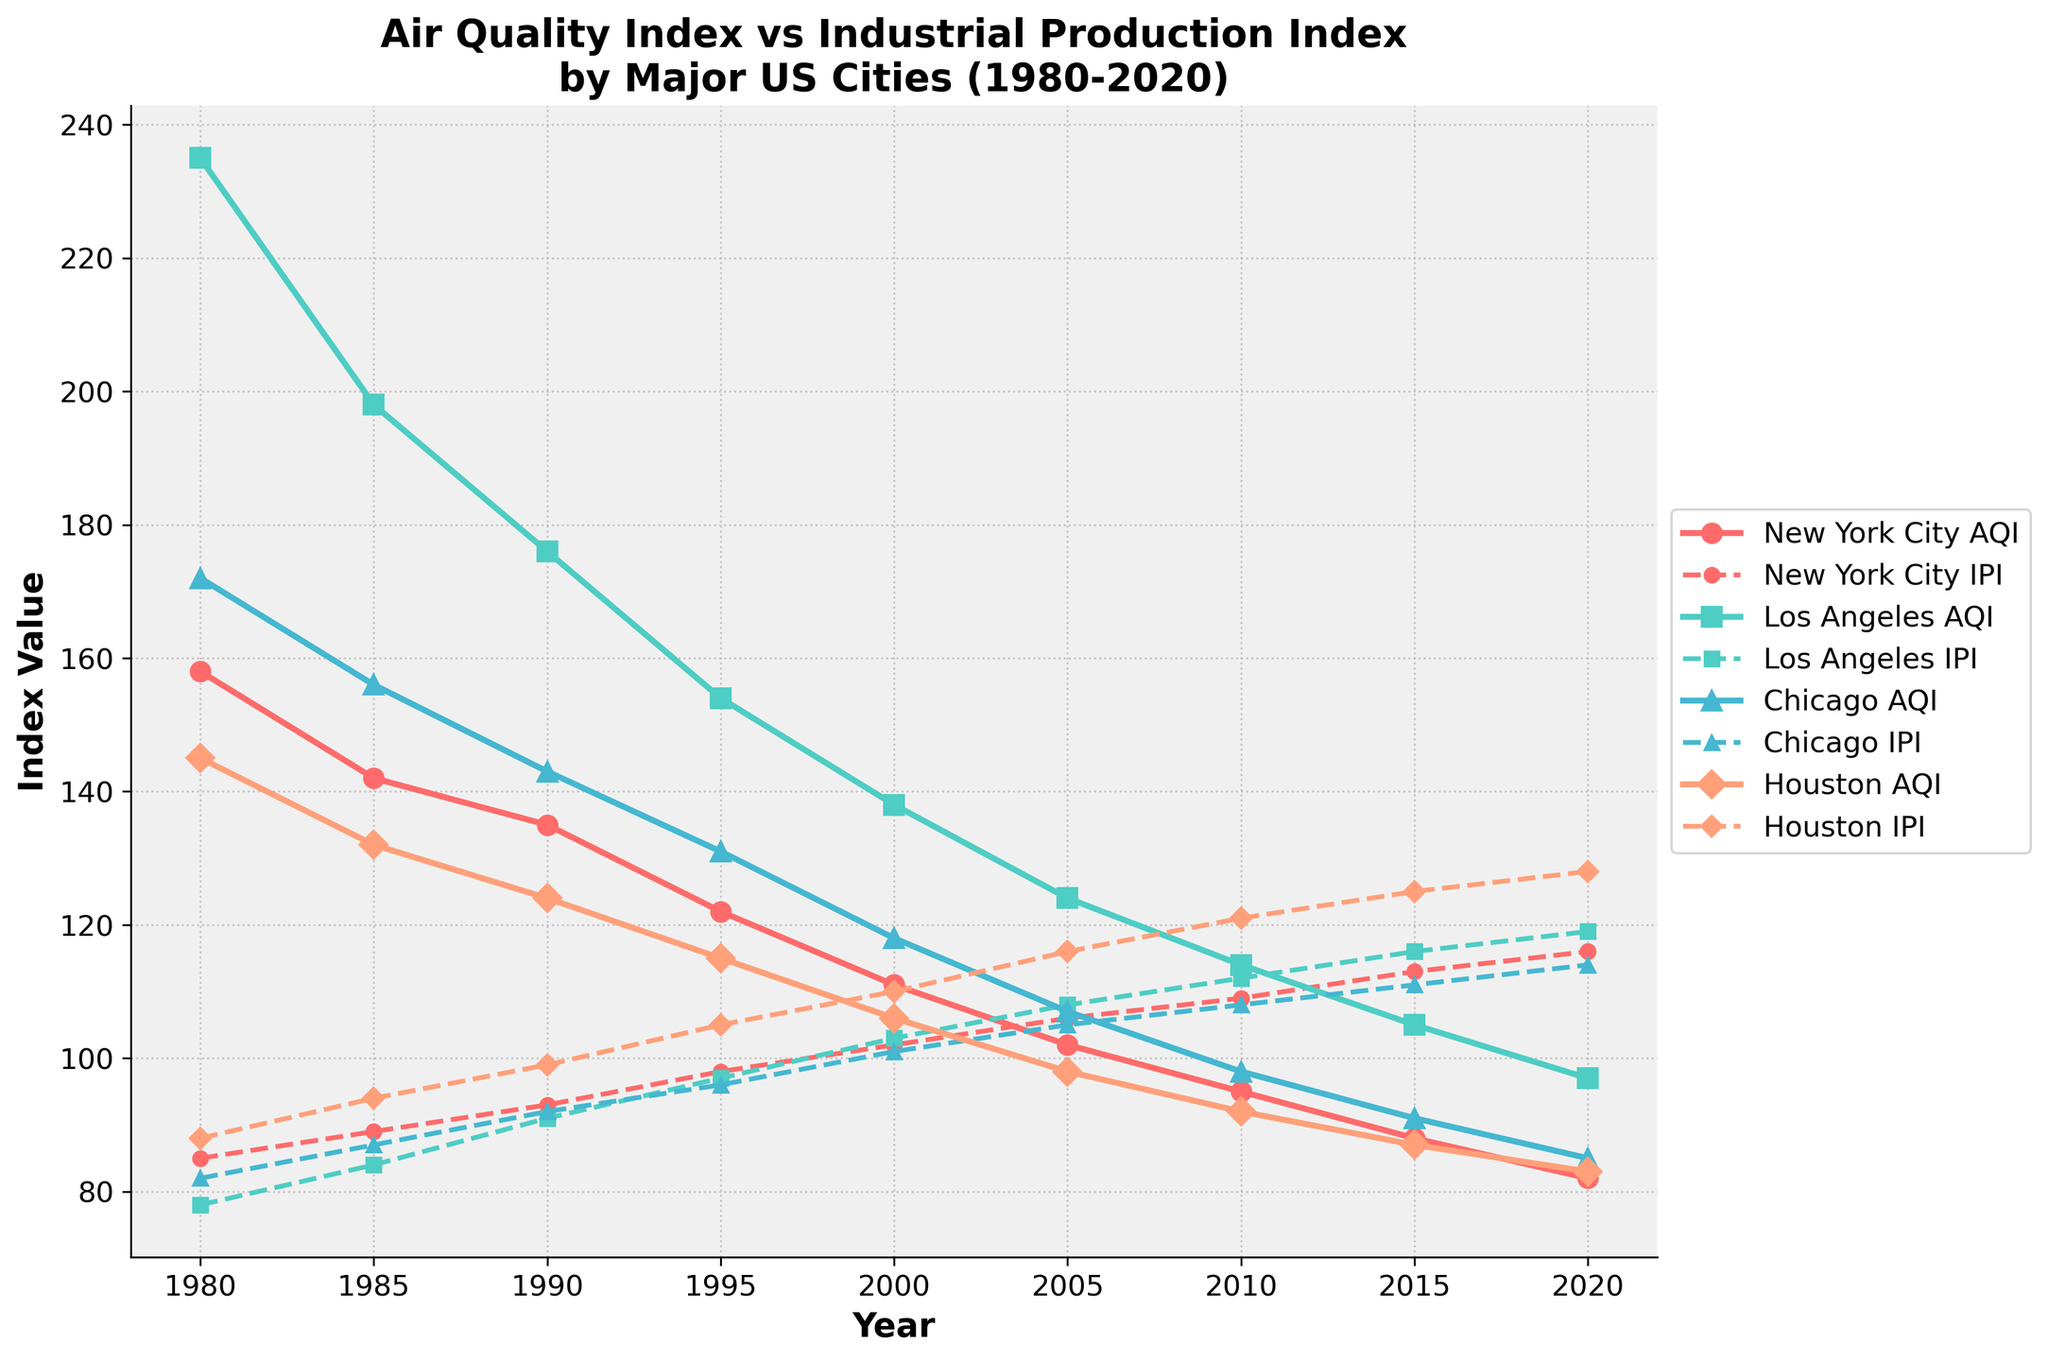What's the general trend of the New York City AQI from 1980 to 2020? The New York City AQI shows a consistent decline over the years, starting at 158 in 1980 and decreasing to 82 in 2020. This indicates an improvement in air quality over this period.
Answer: Decline Are the trends of the AQI and Industrial Production Index for Houston aligned? Observing the figure, Houston's AQI shows a downward trend, starting at 145 in 1980 and reducing to 83 in 2020. In contrast, the Industrial Production Index shows an upward trend, starting at 88 in 1980 and increasing to 128 in 2020.
Answer: No Which city had the highest AQI in the year 1985? By examining the data points for the year 1985 on the figure, Los Angeles had the highest AQI at 198, compared to New York City (142), Chicago (156), and Houston (132).
Answer: Los Angeles Between New York City and Chicago, which city shows a greater overall improvement in AQI from 1980 to 2020? For New York City, the AQI improved from 158 to 82, a reduction of 76 points. For Chicago, the AQI improved from 172 to 85, a reduction of 87 points. Therefore, Chicago shows a greater improvement.
Answer: Chicago What was the AQI difference between Los Angeles and Houston in 2020? In 2020, the AQI for Los Angeles was 97 and for Houston, it was 83. The difference between them is 97 - 83 = 14.
Answer: 14 How does Los Angeles’ trend of AQI compare to its Industrial Production Index over the years? Los Angeles’ AQI shows a downward trend from 235 in 1980 to 97 in 2020. Conversely, its Industrial Production Index shows an upward trend from 78 in 1980 to 119 in 2020. The trends are inversely related.
Answer: Inversely related What is the average AQI of Chicago for the years 1980 and 2020? The AQI for Chicago in 1980 was 172 and in 2020 it was 85. The average is (172 + 85) / 2 = 128.5.
Answer: 128.5 Which city had its AQI and Industrial Production Index values closest to each other in 2005? In 2005, Chicago had an AQI of 107 and an Industrial Production Index of 105, which are the closest values compared to other cities.
Answer: Chicago In what year did New York City's Industrial Production Index surpass 100? According to the plot, New York City's Industrial Production Index first surpassed 100 in the year 2000.
Answer: 2000 